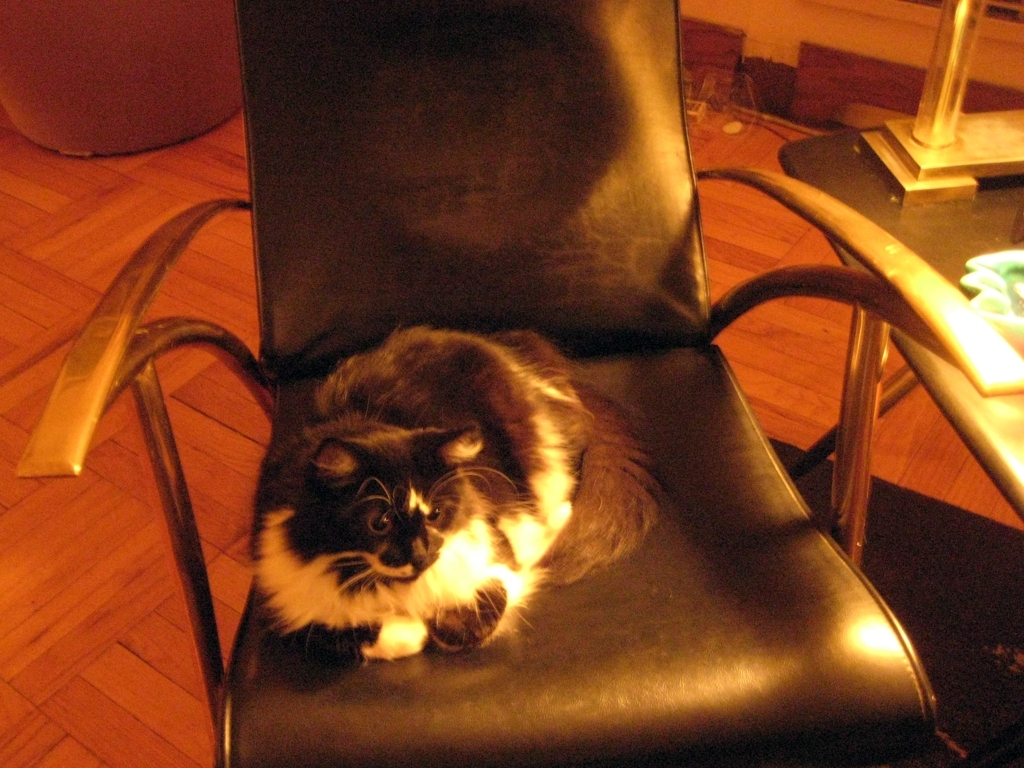Can you tell me more about the design style of the chair? Certainly. The chair exhibits features typical of mid-century modern design, with its clean lines, minimalist aesthetic, and the use of metal and leather materials. The design balances both form and function, exuding an air of elegance and simplicity. 